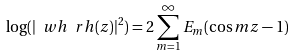Convert formula to latex. <formula><loc_0><loc_0><loc_500><loc_500>\log ( | \ w h \ r h ( z ) | ^ { 2 } ) = 2 \sum _ { m = 1 } ^ { \infty } E _ { m } ( \cos m z - 1 )</formula> 